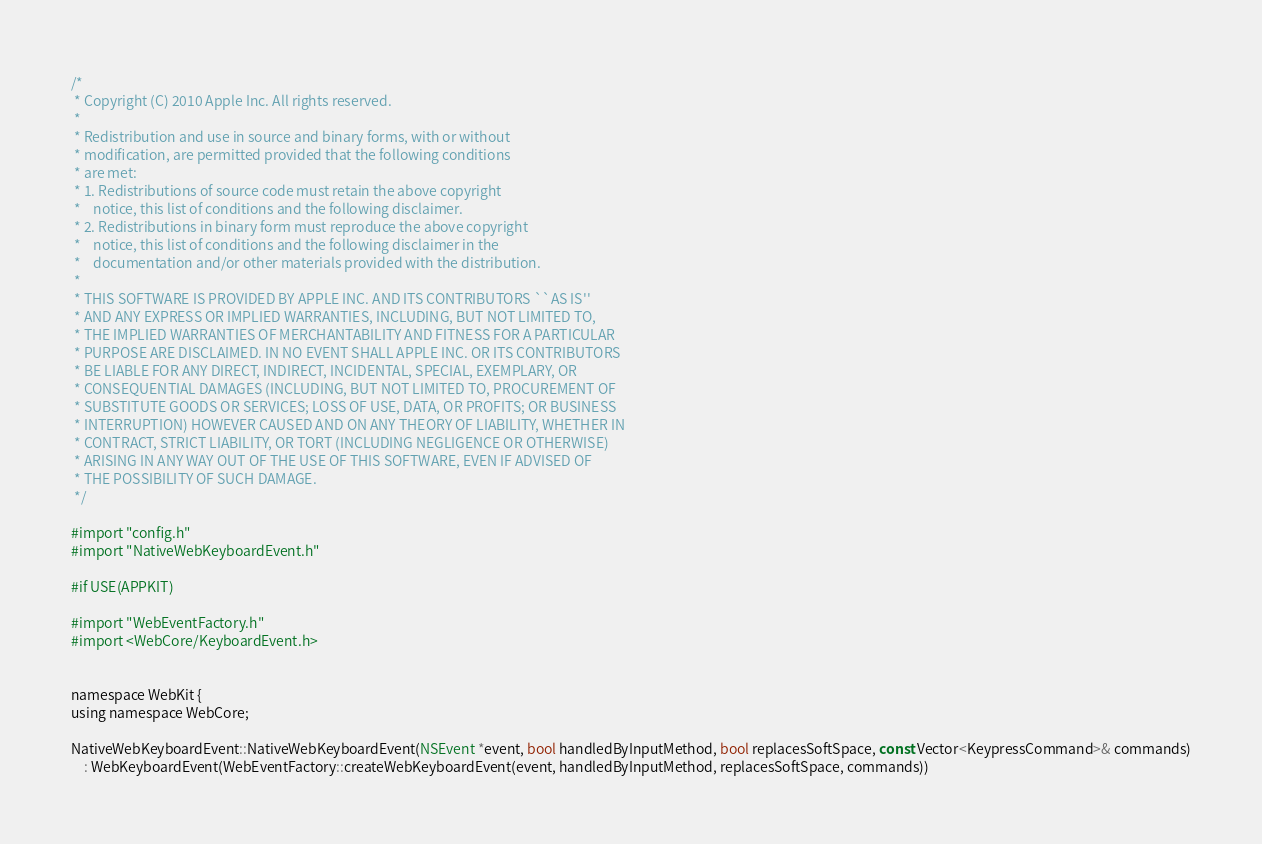<code> <loc_0><loc_0><loc_500><loc_500><_ObjectiveC_>/*
 * Copyright (C) 2010 Apple Inc. All rights reserved.
 *
 * Redistribution and use in source and binary forms, with or without
 * modification, are permitted provided that the following conditions
 * are met:
 * 1. Redistributions of source code must retain the above copyright
 *    notice, this list of conditions and the following disclaimer.
 * 2. Redistributions in binary form must reproduce the above copyright
 *    notice, this list of conditions and the following disclaimer in the
 *    documentation and/or other materials provided with the distribution.
 *
 * THIS SOFTWARE IS PROVIDED BY APPLE INC. AND ITS CONTRIBUTORS ``AS IS''
 * AND ANY EXPRESS OR IMPLIED WARRANTIES, INCLUDING, BUT NOT LIMITED TO,
 * THE IMPLIED WARRANTIES OF MERCHANTABILITY AND FITNESS FOR A PARTICULAR
 * PURPOSE ARE DISCLAIMED. IN NO EVENT SHALL APPLE INC. OR ITS CONTRIBUTORS
 * BE LIABLE FOR ANY DIRECT, INDIRECT, INCIDENTAL, SPECIAL, EXEMPLARY, OR
 * CONSEQUENTIAL DAMAGES (INCLUDING, BUT NOT LIMITED TO, PROCUREMENT OF
 * SUBSTITUTE GOODS OR SERVICES; LOSS OF USE, DATA, OR PROFITS; OR BUSINESS
 * INTERRUPTION) HOWEVER CAUSED AND ON ANY THEORY OF LIABILITY, WHETHER IN
 * CONTRACT, STRICT LIABILITY, OR TORT (INCLUDING NEGLIGENCE OR OTHERWISE)
 * ARISING IN ANY WAY OUT OF THE USE OF THIS SOFTWARE, EVEN IF ADVISED OF
 * THE POSSIBILITY OF SUCH DAMAGE.
 */

#import "config.h"
#import "NativeWebKeyboardEvent.h"

#if USE(APPKIT)

#import "WebEventFactory.h"
#import <WebCore/KeyboardEvent.h>


namespace WebKit {
using namespace WebCore;

NativeWebKeyboardEvent::NativeWebKeyboardEvent(NSEvent *event, bool handledByInputMethod, bool replacesSoftSpace, const Vector<KeypressCommand>& commands)
    : WebKeyboardEvent(WebEventFactory::createWebKeyboardEvent(event, handledByInputMethod, replacesSoftSpace, commands))</code> 